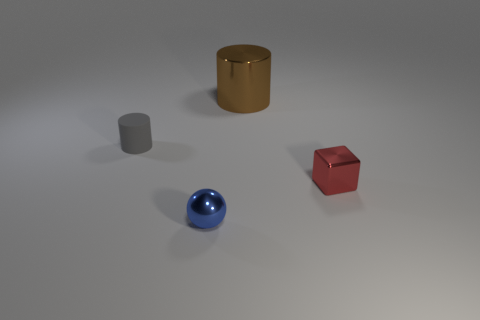Is there anything else that is the same size as the brown cylinder?
Keep it short and to the point. No. Is the number of small red shiny things on the left side of the large metallic thing less than the number of metallic cylinders that are to the right of the tiny metal ball?
Your response must be concise. Yes. How many other objects are there of the same shape as the tiny red metal object?
Your answer should be compact. 0. What is the size of the metal object in front of the shiny thing right of the metallic thing that is behind the tiny gray rubber cylinder?
Ensure brevity in your answer.  Small. What number of green things are either cylinders or large matte cylinders?
Offer a very short reply. 0. What is the shape of the tiny matte object on the left side of the small object that is in front of the small red thing?
Offer a terse response. Cylinder. Does the metal ball in front of the tiny cube have the same size as the metal block to the right of the brown cylinder?
Your answer should be very brief. Yes. Are there any tiny cubes made of the same material as the big brown cylinder?
Make the answer very short. Yes. Are there any small gray cylinders in front of the tiny red metallic object in front of the metal thing that is behind the gray matte thing?
Give a very brief answer. No. Are there any cubes behind the tiny rubber thing?
Provide a short and direct response. No. 